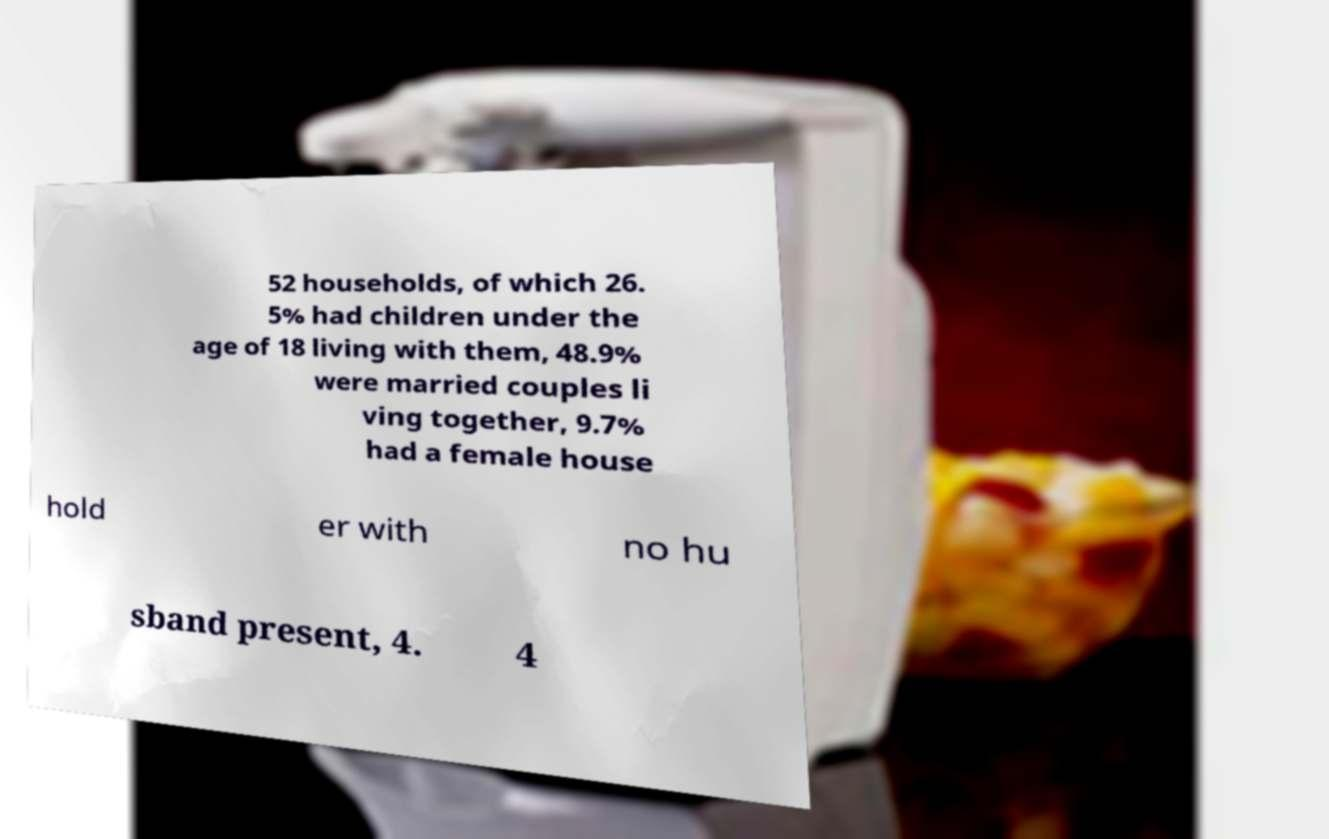For documentation purposes, I need the text within this image transcribed. Could you provide that? 52 households, of which 26. 5% had children under the age of 18 living with them, 48.9% were married couples li ving together, 9.7% had a female house hold er with no hu sband present, 4. 4 